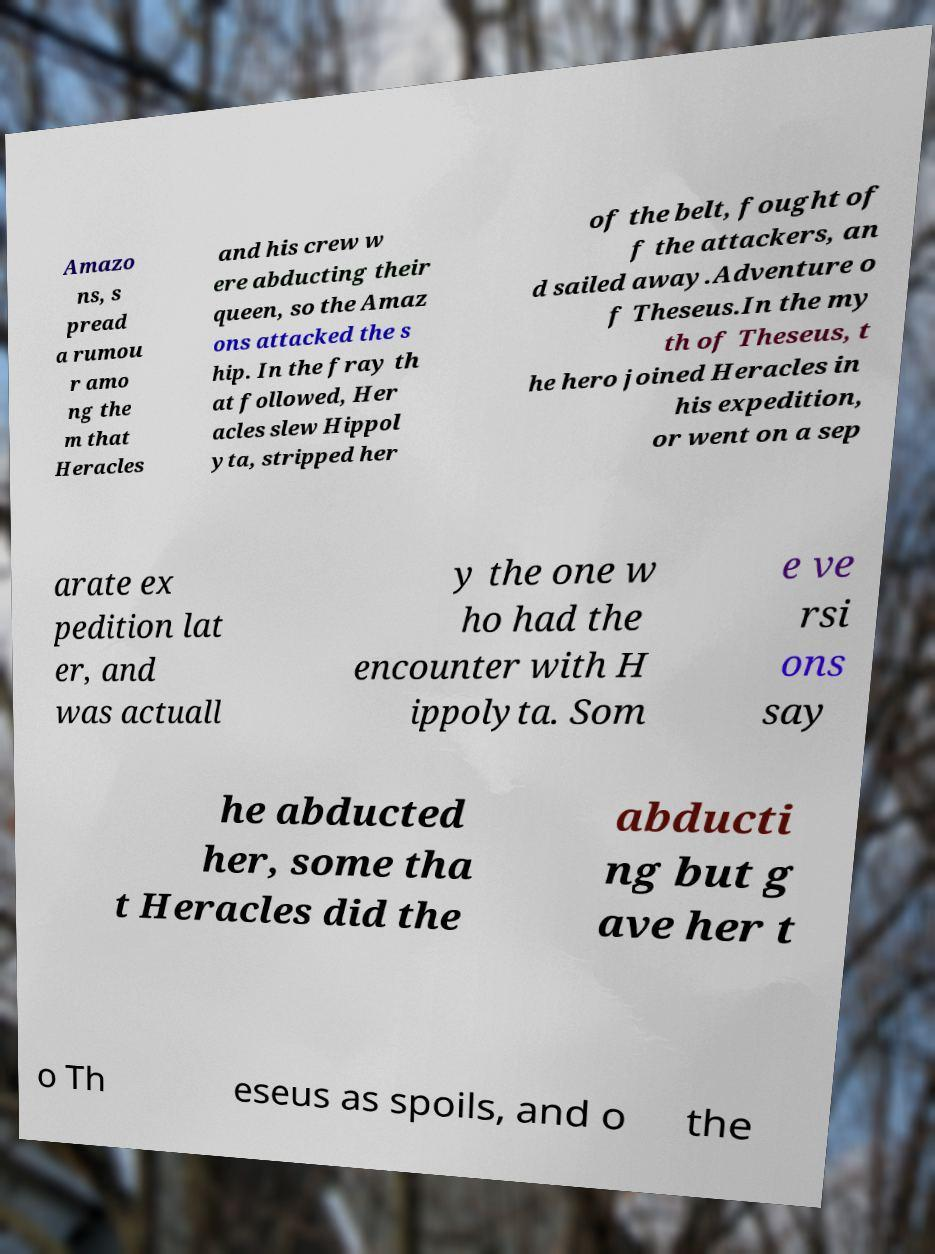There's text embedded in this image that I need extracted. Can you transcribe it verbatim? Amazo ns, s pread a rumou r amo ng the m that Heracles and his crew w ere abducting their queen, so the Amaz ons attacked the s hip. In the fray th at followed, Her acles slew Hippol yta, stripped her of the belt, fought of f the attackers, an d sailed away.Adventure o f Theseus.In the my th of Theseus, t he hero joined Heracles in his expedition, or went on a sep arate ex pedition lat er, and was actuall y the one w ho had the encounter with H ippolyta. Som e ve rsi ons say he abducted her, some tha t Heracles did the abducti ng but g ave her t o Th eseus as spoils, and o the 